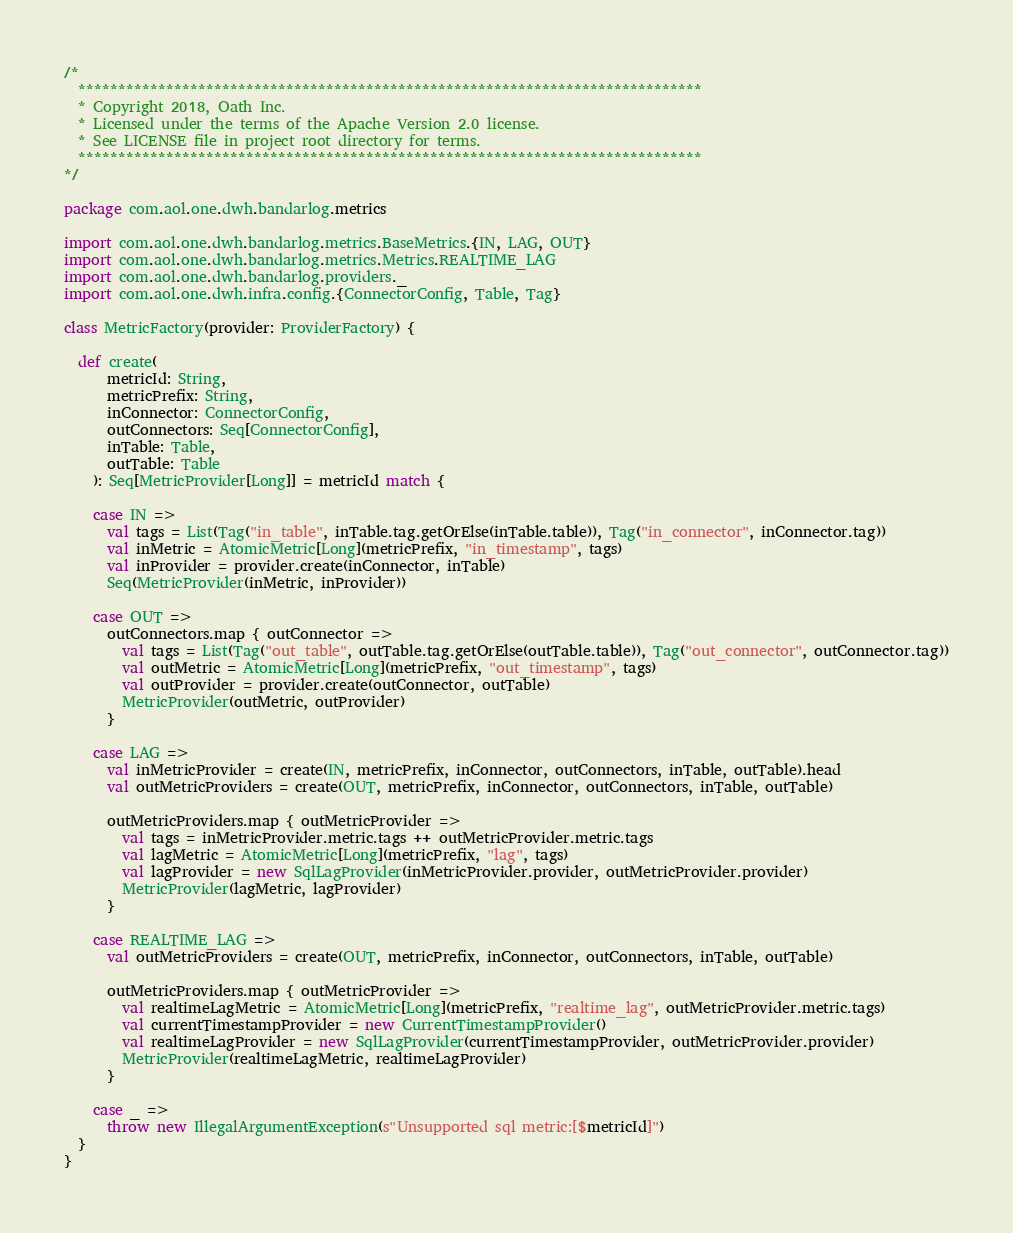<code> <loc_0><loc_0><loc_500><loc_500><_Scala_>/*
  ******************************************************************************
  * Copyright 2018, Oath Inc.
  * Licensed under the terms of the Apache Version 2.0 license.
  * See LICENSE file in project root directory for terms.
  ******************************************************************************
*/

package com.aol.one.dwh.bandarlog.metrics

import com.aol.one.dwh.bandarlog.metrics.BaseMetrics.{IN, LAG, OUT}
import com.aol.one.dwh.bandarlog.metrics.Metrics.REALTIME_LAG
import com.aol.one.dwh.bandarlog.providers._
import com.aol.one.dwh.infra.config.{ConnectorConfig, Table, Tag}

class MetricFactory(provider: ProviderFactory) {

  def create(
      metricId: String,
      metricPrefix: String,
      inConnector: ConnectorConfig,
      outConnectors: Seq[ConnectorConfig],
      inTable: Table,
      outTable: Table
    ): Seq[MetricProvider[Long]] = metricId match {

    case IN =>
      val tags = List(Tag("in_table", inTable.tag.getOrElse(inTable.table)), Tag("in_connector", inConnector.tag))
      val inMetric = AtomicMetric[Long](metricPrefix, "in_timestamp", tags)
      val inProvider = provider.create(inConnector, inTable)
      Seq(MetricProvider(inMetric, inProvider))

    case OUT =>
      outConnectors.map { outConnector =>
        val tags = List(Tag("out_table", outTable.tag.getOrElse(outTable.table)), Tag("out_connector", outConnector.tag))
        val outMetric = AtomicMetric[Long](metricPrefix, "out_timestamp", tags)
        val outProvider = provider.create(outConnector, outTable)
        MetricProvider(outMetric, outProvider)
      }

    case LAG =>
      val inMetricProvider = create(IN, metricPrefix, inConnector, outConnectors, inTable, outTable).head
      val outMetricProviders = create(OUT, metricPrefix, inConnector, outConnectors, inTable, outTable)

      outMetricProviders.map { outMetricProvider =>
        val tags = inMetricProvider.metric.tags ++ outMetricProvider.metric.tags
        val lagMetric = AtomicMetric[Long](metricPrefix, "lag", tags)
        val lagProvider = new SqlLagProvider(inMetricProvider.provider, outMetricProvider.provider)
        MetricProvider(lagMetric, lagProvider)
      }

    case REALTIME_LAG =>
      val outMetricProviders = create(OUT, metricPrefix, inConnector, outConnectors, inTable, outTable)

      outMetricProviders.map { outMetricProvider =>
        val realtimeLagMetric = AtomicMetric[Long](metricPrefix, "realtime_lag", outMetricProvider.metric.tags)
        val currentTimestampProvider = new CurrentTimestampProvider()
        val realtimeLagProvider = new SqlLagProvider(currentTimestampProvider, outMetricProvider.provider)
        MetricProvider(realtimeLagMetric, realtimeLagProvider)
      }

    case _ =>
      throw new IllegalArgumentException(s"Unsupported sql metric:[$metricId]")
  }
}
</code> 